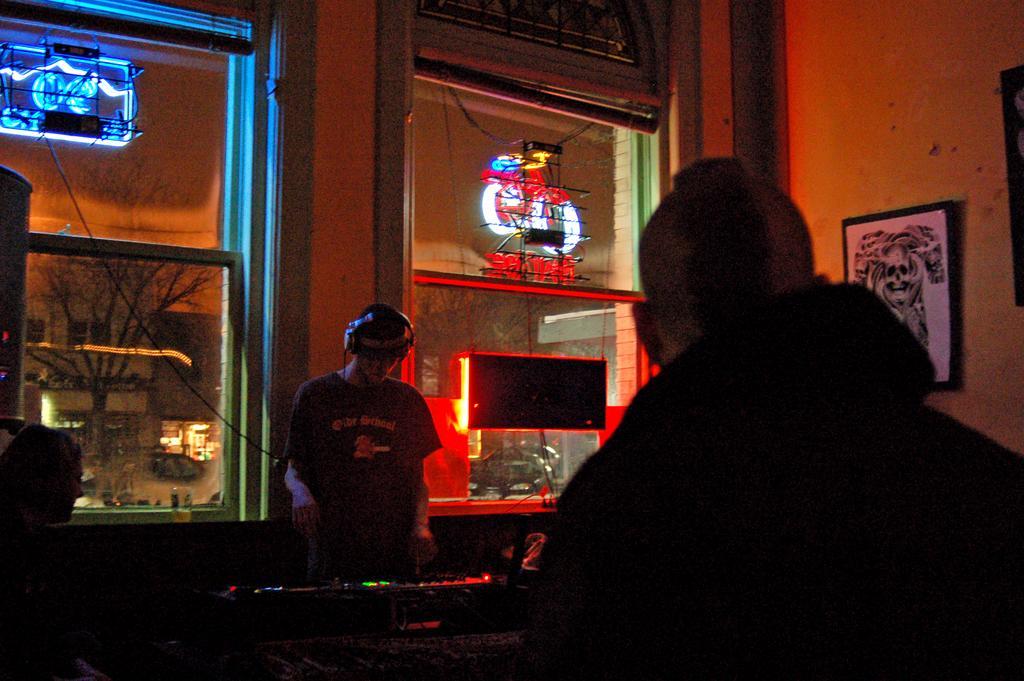Describe this image in one or two sentences. This picture shows a man wore a headset and operating a music system and we see another man standing. He wore a jacket and we see lights. From the glass window we see a building and couple of trees and a car parked and we see few people standing and we see couple of photo frames on the wall. 